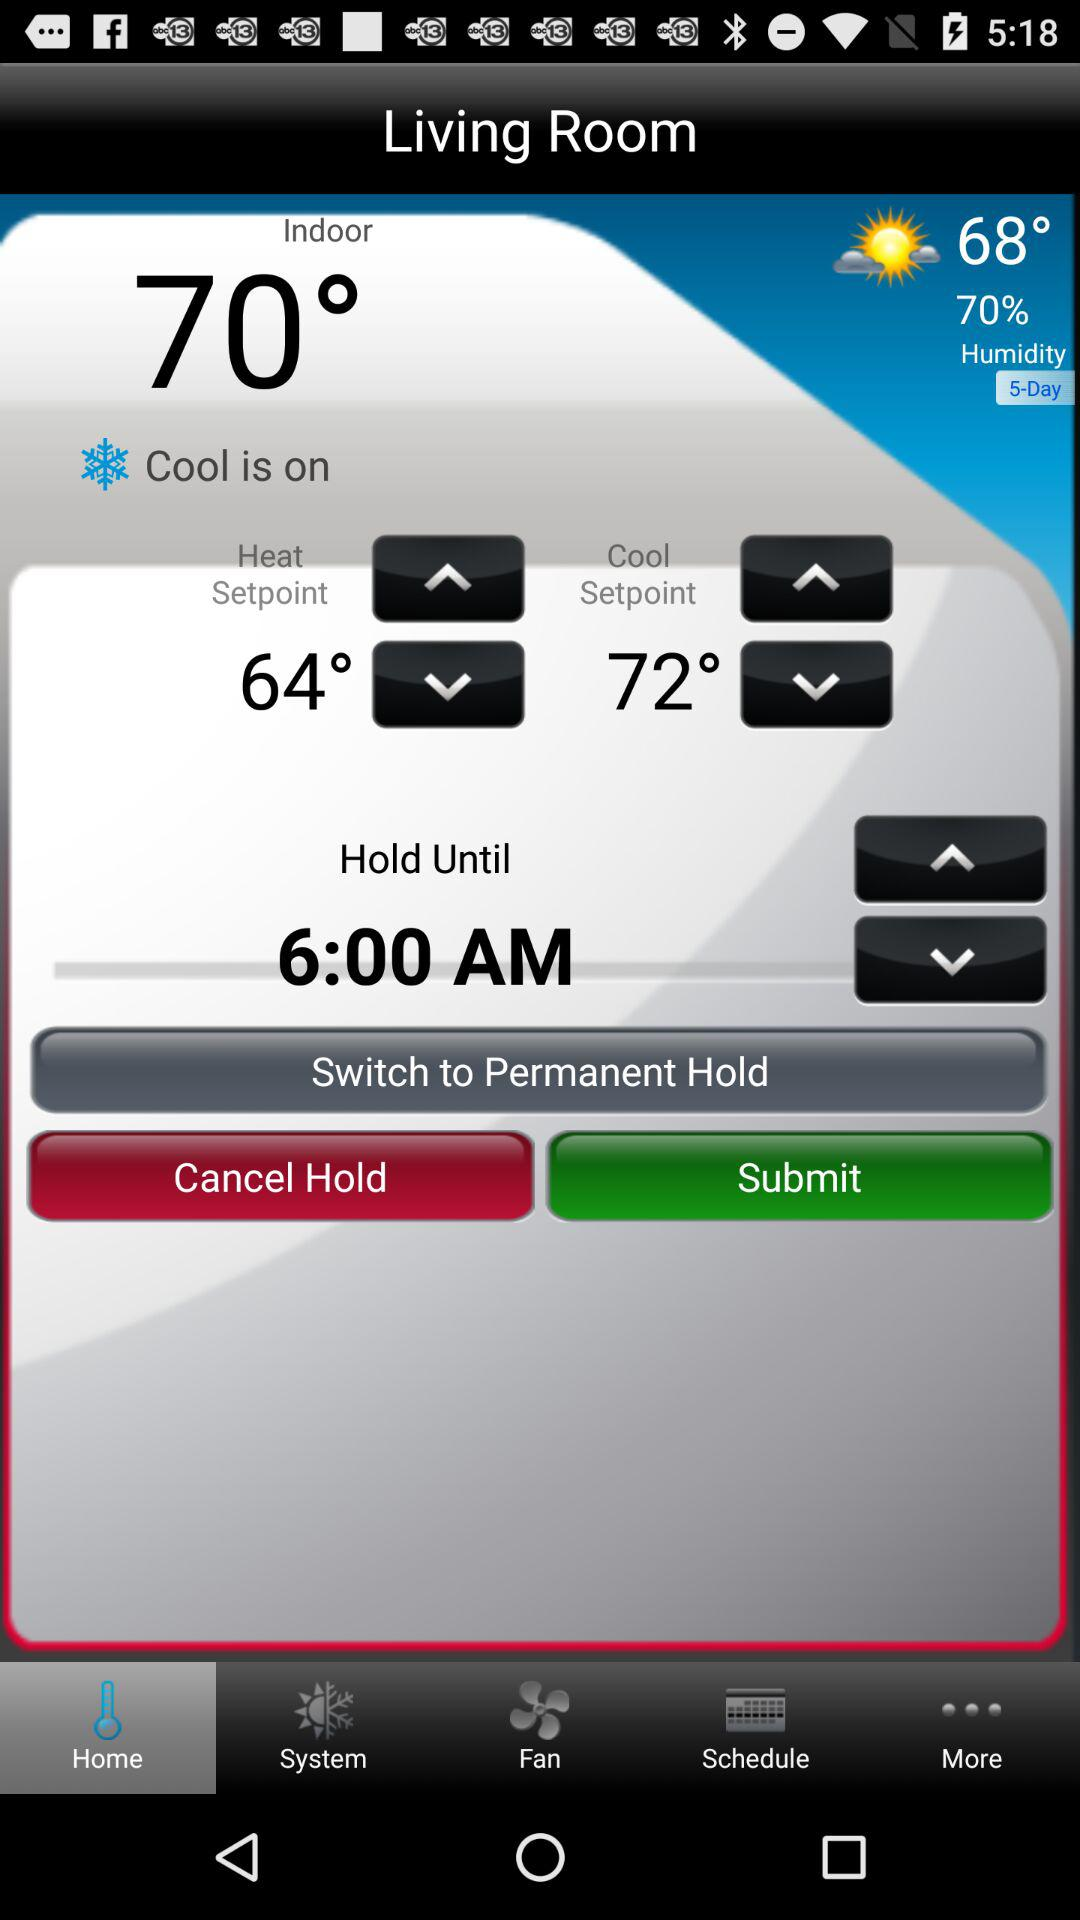How is the weather? The weather is partly cloudy. 